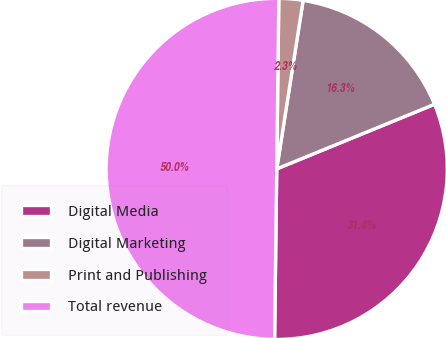<chart> <loc_0><loc_0><loc_500><loc_500><pie_chart><fcel>Digital Media<fcel>Digital Marketing<fcel>Print and Publishing<fcel>Total revenue<nl><fcel>31.39%<fcel>16.34%<fcel>2.28%<fcel>50.0%<nl></chart> 